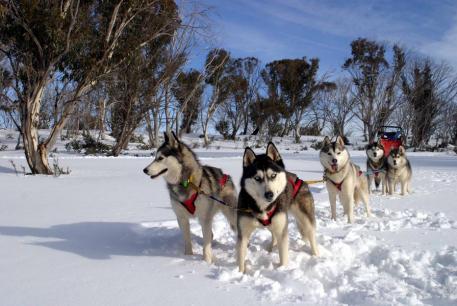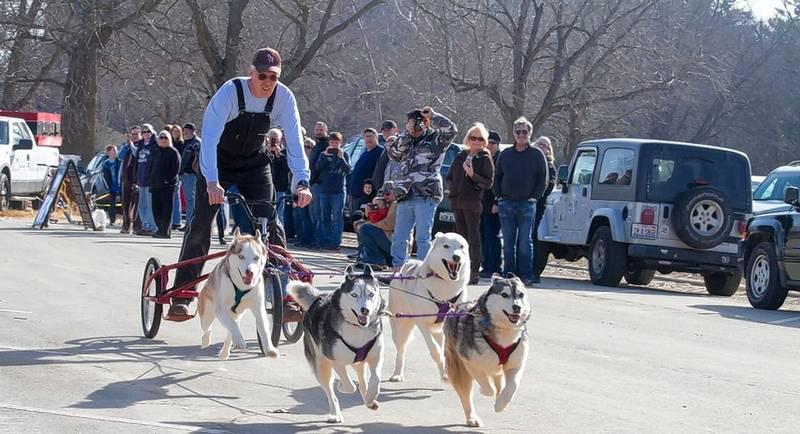The first image is the image on the left, the second image is the image on the right. For the images shown, is this caption "There is snow on the trees in one of the images." true? Answer yes or no. No. 